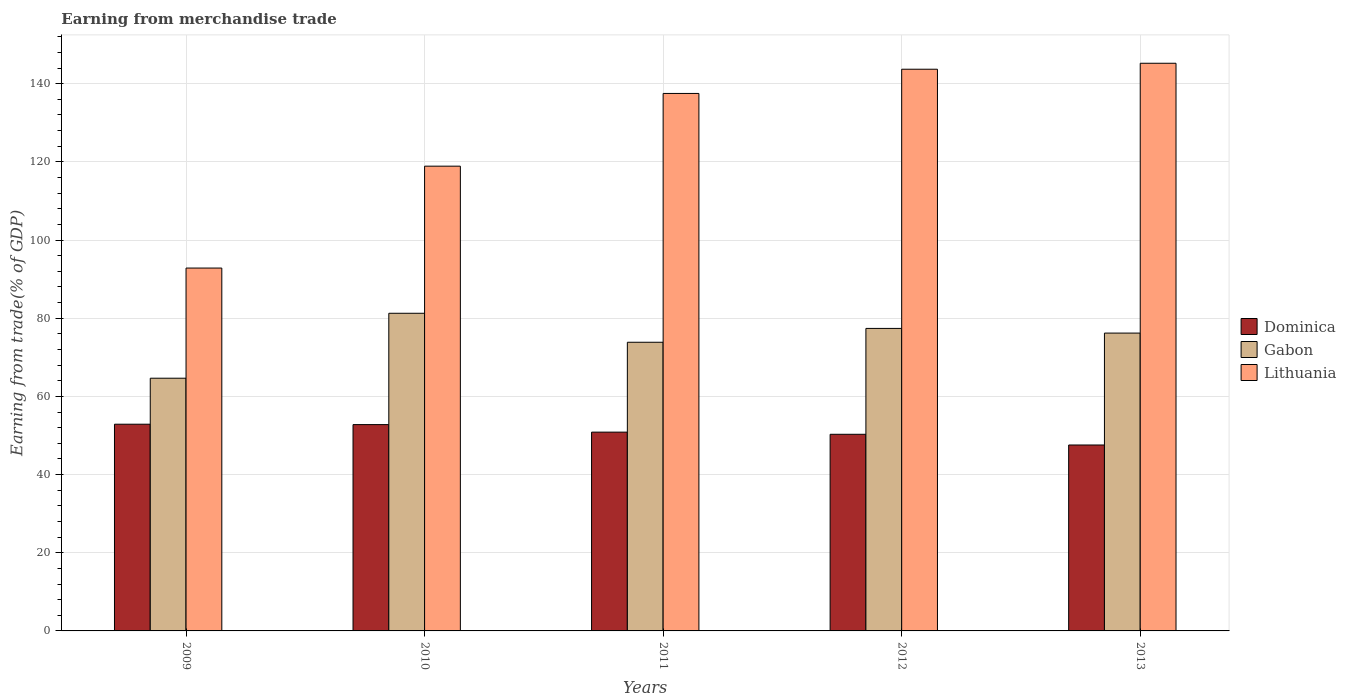How many different coloured bars are there?
Make the answer very short. 3. Are the number of bars on each tick of the X-axis equal?
Your answer should be compact. Yes. How many bars are there on the 2nd tick from the left?
Your answer should be very brief. 3. How many bars are there on the 4th tick from the right?
Give a very brief answer. 3. What is the label of the 5th group of bars from the left?
Your answer should be compact. 2013. What is the earnings from trade in Gabon in 2013?
Your answer should be compact. 76.2. Across all years, what is the maximum earnings from trade in Gabon?
Make the answer very short. 81.26. Across all years, what is the minimum earnings from trade in Gabon?
Give a very brief answer. 64.65. What is the total earnings from trade in Gabon in the graph?
Keep it short and to the point. 373.36. What is the difference between the earnings from trade in Dominica in 2009 and that in 2012?
Provide a succinct answer. 2.58. What is the difference between the earnings from trade in Dominica in 2011 and the earnings from trade in Gabon in 2010?
Give a very brief answer. -30.41. What is the average earnings from trade in Dominica per year?
Give a very brief answer. 50.88. In the year 2010, what is the difference between the earnings from trade in Dominica and earnings from trade in Gabon?
Ensure brevity in your answer.  -28.48. In how many years, is the earnings from trade in Gabon greater than 16 %?
Provide a short and direct response. 5. What is the ratio of the earnings from trade in Gabon in 2009 to that in 2010?
Provide a succinct answer. 0.8. Is the earnings from trade in Dominica in 2011 less than that in 2012?
Provide a succinct answer. No. What is the difference between the highest and the second highest earnings from trade in Gabon?
Your response must be concise. 3.87. What is the difference between the highest and the lowest earnings from trade in Lithuania?
Provide a short and direct response. 52.39. In how many years, is the earnings from trade in Gabon greater than the average earnings from trade in Gabon taken over all years?
Give a very brief answer. 3. What does the 1st bar from the left in 2010 represents?
Offer a terse response. Dominica. What does the 3rd bar from the right in 2009 represents?
Ensure brevity in your answer.  Dominica. What is the difference between two consecutive major ticks on the Y-axis?
Give a very brief answer. 20. Are the values on the major ticks of Y-axis written in scientific E-notation?
Ensure brevity in your answer.  No. Does the graph contain grids?
Keep it short and to the point. Yes. Where does the legend appear in the graph?
Provide a succinct answer. Center right. How are the legend labels stacked?
Ensure brevity in your answer.  Vertical. What is the title of the graph?
Offer a terse response. Earning from merchandise trade. Does "Swaziland" appear as one of the legend labels in the graph?
Offer a very short reply. No. What is the label or title of the X-axis?
Give a very brief answer. Years. What is the label or title of the Y-axis?
Your answer should be very brief. Earning from trade(% of GDP). What is the Earning from trade(% of GDP) in Dominica in 2009?
Give a very brief answer. 52.88. What is the Earning from trade(% of GDP) of Gabon in 2009?
Give a very brief answer. 64.65. What is the Earning from trade(% of GDP) of Lithuania in 2009?
Offer a terse response. 92.84. What is the Earning from trade(% of GDP) of Dominica in 2010?
Your response must be concise. 52.78. What is the Earning from trade(% of GDP) in Gabon in 2010?
Make the answer very short. 81.26. What is the Earning from trade(% of GDP) of Lithuania in 2010?
Provide a short and direct response. 118.9. What is the Earning from trade(% of GDP) in Dominica in 2011?
Provide a succinct answer. 50.86. What is the Earning from trade(% of GDP) of Gabon in 2011?
Provide a succinct answer. 73.85. What is the Earning from trade(% of GDP) in Lithuania in 2011?
Your answer should be compact. 137.51. What is the Earning from trade(% of GDP) in Dominica in 2012?
Offer a very short reply. 50.3. What is the Earning from trade(% of GDP) in Gabon in 2012?
Ensure brevity in your answer.  77.39. What is the Earning from trade(% of GDP) of Lithuania in 2012?
Keep it short and to the point. 143.7. What is the Earning from trade(% of GDP) in Dominica in 2013?
Your answer should be compact. 47.57. What is the Earning from trade(% of GDP) in Gabon in 2013?
Keep it short and to the point. 76.2. What is the Earning from trade(% of GDP) of Lithuania in 2013?
Offer a very short reply. 145.23. Across all years, what is the maximum Earning from trade(% of GDP) of Dominica?
Ensure brevity in your answer.  52.88. Across all years, what is the maximum Earning from trade(% of GDP) of Gabon?
Make the answer very short. 81.26. Across all years, what is the maximum Earning from trade(% of GDP) in Lithuania?
Ensure brevity in your answer.  145.23. Across all years, what is the minimum Earning from trade(% of GDP) of Dominica?
Your answer should be very brief. 47.57. Across all years, what is the minimum Earning from trade(% of GDP) of Gabon?
Your answer should be compact. 64.65. Across all years, what is the minimum Earning from trade(% of GDP) in Lithuania?
Give a very brief answer. 92.84. What is the total Earning from trade(% of GDP) of Dominica in the graph?
Ensure brevity in your answer.  254.4. What is the total Earning from trade(% of GDP) in Gabon in the graph?
Your answer should be very brief. 373.36. What is the total Earning from trade(% of GDP) of Lithuania in the graph?
Give a very brief answer. 638.18. What is the difference between the Earning from trade(% of GDP) of Dominica in 2009 and that in 2010?
Keep it short and to the point. 0.1. What is the difference between the Earning from trade(% of GDP) of Gabon in 2009 and that in 2010?
Your answer should be compact. -16.61. What is the difference between the Earning from trade(% of GDP) in Lithuania in 2009 and that in 2010?
Offer a terse response. -26.07. What is the difference between the Earning from trade(% of GDP) in Dominica in 2009 and that in 2011?
Ensure brevity in your answer.  2.03. What is the difference between the Earning from trade(% of GDP) in Gabon in 2009 and that in 2011?
Offer a terse response. -9.2. What is the difference between the Earning from trade(% of GDP) in Lithuania in 2009 and that in 2011?
Offer a terse response. -44.67. What is the difference between the Earning from trade(% of GDP) in Dominica in 2009 and that in 2012?
Keep it short and to the point. 2.58. What is the difference between the Earning from trade(% of GDP) in Gabon in 2009 and that in 2012?
Keep it short and to the point. -12.74. What is the difference between the Earning from trade(% of GDP) of Lithuania in 2009 and that in 2012?
Provide a succinct answer. -50.87. What is the difference between the Earning from trade(% of GDP) in Dominica in 2009 and that in 2013?
Your answer should be compact. 5.32. What is the difference between the Earning from trade(% of GDP) in Gabon in 2009 and that in 2013?
Provide a succinct answer. -11.54. What is the difference between the Earning from trade(% of GDP) of Lithuania in 2009 and that in 2013?
Provide a short and direct response. -52.39. What is the difference between the Earning from trade(% of GDP) in Dominica in 2010 and that in 2011?
Keep it short and to the point. 1.93. What is the difference between the Earning from trade(% of GDP) in Gabon in 2010 and that in 2011?
Make the answer very short. 7.42. What is the difference between the Earning from trade(% of GDP) of Lithuania in 2010 and that in 2011?
Offer a very short reply. -18.61. What is the difference between the Earning from trade(% of GDP) of Dominica in 2010 and that in 2012?
Your answer should be compact. 2.48. What is the difference between the Earning from trade(% of GDP) in Gabon in 2010 and that in 2012?
Provide a succinct answer. 3.87. What is the difference between the Earning from trade(% of GDP) of Lithuania in 2010 and that in 2012?
Your response must be concise. -24.8. What is the difference between the Earning from trade(% of GDP) of Dominica in 2010 and that in 2013?
Provide a succinct answer. 5.22. What is the difference between the Earning from trade(% of GDP) of Gabon in 2010 and that in 2013?
Provide a succinct answer. 5.07. What is the difference between the Earning from trade(% of GDP) in Lithuania in 2010 and that in 2013?
Your answer should be very brief. -26.33. What is the difference between the Earning from trade(% of GDP) of Dominica in 2011 and that in 2012?
Keep it short and to the point. 0.56. What is the difference between the Earning from trade(% of GDP) in Gabon in 2011 and that in 2012?
Your answer should be compact. -3.54. What is the difference between the Earning from trade(% of GDP) in Lithuania in 2011 and that in 2012?
Provide a succinct answer. -6.2. What is the difference between the Earning from trade(% of GDP) in Dominica in 2011 and that in 2013?
Provide a succinct answer. 3.29. What is the difference between the Earning from trade(% of GDP) in Gabon in 2011 and that in 2013?
Your answer should be very brief. -2.35. What is the difference between the Earning from trade(% of GDP) of Lithuania in 2011 and that in 2013?
Provide a short and direct response. -7.72. What is the difference between the Earning from trade(% of GDP) in Dominica in 2012 and that in 2013?
Your answer should be compact. 2.74. What is the difference between the Earning from trade(% of GDP) of Gabon in 2012 and that in 2013?
Give a very brief answer. 1.2. What is the difference between the Earning from trade(% of GDP) of Lithuania in 2012 and that in 2013?
Keep it short and to the point. -1.53. What is the difference between the Earning from trade(% of GDP) in Dominica in 2009 and the Earning from trade(% of GDP) in Gabon in 2010?
Provide a succinct answer. -28.38. What is the difference between the Earning from trade(% of GDP) of Dominica in 2009 and the Earning from trade(% of GDP) of Lithuania in 2010?
Provide a short and direct response. -66.02. What is the difference between the Earning from trade(% of GDP) in Gabon in 2009 and the Earning from trade(% of GDP) in Lithuania in 2010?
Your response must be concise. -54.25. What is the difference between the Earning from trade(% of GDP) in Dominica in 2009 and the Earning from trade(% of GDP) in Gabon in 2011?
Give a very brief answer. -20.97. What is the difference between the Earning from trade(% of GDP) in Dominica in 2009 and the Earning from trade(% of GDP) in Lithuania in 2011?
Offer a terse response. -84.62. What is the difference between the Earning from trade(% of GDP) of Gabon in 2009 and the Earning from trade(% of GDP) of Lithuania in 2011?
Offer a terse response. -72.85. What is the difference between the Earning from trade(% of GDP) of Dominica in 2009 and the Earning from trade(% of GDP) of Gabon in 2012?
Your answer should be compact. -24.51. What is the difference between the Earning from trade(% of GDP) of Dominica in 2009 and the Earning from trade(% of GDP) of Lithuania in 2012?
Offer a terse response. -90.82. What is the difference between the Earning from trade(% of GDP) in Gabon in 2009 and the Earning from trade(% of GDP) in Lithuania in 2012?
Offer a very short reply. -79.05. What is the difference between the Earning from trade(% of GDP) of Dominica in 2009 and the Earning from trade(% of GDP) of Gabon in 2013?
Your answer should be compact. -23.31. What is the difference between the Earning from trade(% of GDP) of Dominica in 2009 and the Earning from trade(% of GDP) of Lithuania in 2013?
Provide a succinct answer. -92.34. What is the difference between the Earning from trade(% of GDP) of Gabon in 2009 and the Earning from trade(% of GDP) of Lithuania in 2013?
Offer a terse response. -80.58. What is the difference between the Earning from trade(% of GDP) in Dominica in 2010 and the Earning from trade(% of GDP) in Gabon in 2011?
Offer a terse response. -21.07. What is the difference between the Earning from trade(% of GDP) of Dominica in 2010 and the Earning from trade(% of GDP) of Lithuania in 2011?
Your answer should be very brief. -84.72. What is the difference between the Earning from trade(% of GDP) of Gabon in 2010 and the Earning from trade(% of GDP) of Lithuania in 2011?
Your response must be concise. -56.24. What is the difference between the Earning from trade(% of GDP) in Dominica in 2010 and the Earning from trade(% of GDP) in Gabon in 2012?
Ensure brevity in your answer.  -24.61. What is the difference between the Earning from trade(% of GDP) in Dominica in 2010 and the Earning from trade(% of GDP) in Lithuania in 2012?
Make the answer very short. -90.92. What is the difference between the Earning from trade(% of GDP) in Gabon in 2010 and the Earning from trade(% of GDP) in Lithuania in 2012?
Give a very brief answer. -62.44. What is the difference between the Earning from trade(% of GDP) in Dominica in 2010 and the Earning from trade(% of GDP) in Gabon in 2013?
Your response must be concise. -23.41. What is the difference between the Earning from trade(% of GDP) of Dominica in 2010 and the Earning from trade(% of GDP) of Lithuania in 2013?
Give a very brief answer. -92.44. What is the difference between the Earning from trade(% of GDP) in Gabon in 2010 and the Earning from trade(% of GDP) in Lithuania in 2013?
Keep it short and to the point. -63.96. What is the difference between the Earning from trade(% of GDP) of Dominica in 2011 and the Earning from trade(% of GDP) of Gabon in 2012?
Provide a succinct answer. -26.53. What is the difference between the Earning from trade(% of GDP) of Dominica in 2011 and the Earning from trade(% of GDP) of Lithuania in 2012?
Give a very brief answer. -92.84. What is the difference between the Earning from trade(% of GDP) of Gabon in 2011 and the Earning from trade(% of GDP) of Lithuania in 2012?
Make the answer very short. -69.85. What is the difference between the Earning from trade(% of GDP) in Dominica in 2011 and the Earning from trade(% of GDP) in Gabon in 2013?
Make the answer very short. -25.34. What is the difference between the Earning from trade(% of GDP) in Dominica in 2011 and the Earning from trade(% of GDP) in Lithuania in 2013?
Ensure brevity in your answer.  -94.37. What is the difference between the Earning from trade(% of GDP) of Gabon in 2011 and the Earning from trade(% of GDP) of Lithuania in 2013?
Give a very brief answer. -71.38. What is the difference between the Earning from trade(% of GDP) in Dominica in 2012 and the Earning from trade(% of GDP) in Gabon in 2013?
Give a very brief answer. -25.89. What is the difference between the Earning from trade(% of GDP) of Dominica in 2012 and the Earning from trade(% of GDP) of Lithuania in 2013?
Ensure brevity in your answer.  -94.92. What is the difference between the Earning from trade(% of GDP) of Gabon in 2012 and the Earning from trade(% of GDP) of Lithuania in 2013?
Ensure brevity in your answer.  -67.84. What is the average Earning from trade(% of GDP) in Dominica per year?
Give a very brief answer. 50.88. What is the average Earning from trade(% of GDP) of Gabon per year?
Your response must be concise. 74.67. What is the average Earning from trade(% of GDP) in Lithuania per year?
Offer a terse response. 127.64. In the year 2009, what is the difference between the Earning from trade(% of GDP) in Dominica and Earning from trade(% of GDP) in Gabon?
Your answer should be very brief. -11.77. In the year 2009, what is the difference between the Earning from trade(% of GDP) of Dominica and Earning from trade(% of GDP) of Lithuania?
Your answer should be compact. -39.95. In the year 2009, what is the difference between the Earning from trade(% of GDP) of Gabon and Earning from trade(% of GDP) of Lithuania?
Your response must be concise. -28.18. In the year 2010, what is the difference between the Earning from trade(% of GDP) of Dominica and Earning from trade(% of GDP) of Gabon?
Make the answer very short. -28.48. In the year 2010, what is the difference between the Earning from trade(% of GDP) in Dominica and Earning from trade(% of GDP) in Lithuania?
Your answer should be very brief. -66.12. In the year 2010, what is the difference between the Earning from trade(% of GDP) of Gabon and Earning from trade(% of GDP) of Lithuania?
Give a very brief answer. -37.64. In the year 2011, what is the difference between the Earning from trade(% of GDP) in Dominica and Earning from trade(% of GDP) in Gabon?
Offer a terse response. -22.99. In the year 2011, what is the difference between the Earning from trade(% of GDP) of Dominica and Earning from trade(% of GDP) of Lithuania?
Ensure brevity in your answer.  -86.65. In the year 2011, what is the difference between the Earning from trade(% of GDP) in Gabon and Earning from trade(% of GDP) in Lithuania?
Your answer should be compact. -63.66. In the year 2012, what is the difference between the Earning from trade(% of GDP) of Dominica and Earning from trade(% of GDP) of Gabon?
Provide a succinct answer. -27.09. In the year 2012, what is the difference between the Earning from trade(% of GDP) of Dominica and Earning from trade(% of GDP) of Lithuania?
Offer a terse response. -93.4. In the year 2012, what is the difference between the Earning from trade(% of GDP) in Gabon and Earning from trade(% of GDP) in Lithuania?
Your answer should be very brief. -66.31. In the year 2013, what is the difference between the Earning from trade(% of GDP) of Dominica and Earning from trade(% of GDP) of Gabon?
Offer a terse response. -28.63. In the year 2013, what is the difference between the Earning from trade(% of GDP) in Dominica and Earning from trade(% of GDP) in Lithuania?
Give a very brief answer. -97.66. In the year 2013, what is the difference between the Earning from trade(% of GDP) of Gabon and Earning from trade(% of GDP) of Lithuania?
Your response must be concise. -69.03. What is the ratio of the Earning from trade(% of GDP) in Dominica in 2009 to that in 2010?
Provide a short and direct response. 1. What is the ratio of the Earning from trade(% of GDP) of Gabon in 2009 to that in 2010?
Make the answer very short. 0.8. What is the ratio of the Earning from trade(% of GDP) in Lithuania in 2009 to that in 2010?
Keep it short and to the point. 0.78. What is the ratio of the Earning from trade(% of GDP) of Dominica in 2009 to that in 2011?
Your answer should be very brief. 1.04. What is the ratio of the Earning from trade(% of GDP) of Gabon in 2009 to that in 2011?
Give a very brief answer. 0.88. What is the ratio of the Earning from trade(% of GDP) in Lithuania in 2009 to that in 2011?
Offer a very short reply. 0.68. What is the ratio of the Earning from trade(% of GDP) in Dominica in 2009 to that in 2012?
Your response must be concise. 1.05. What is the ratio of the Earning from trade(% of GDP) of Gabon in 2009 to that in 2012?
Your answer should be compact. 0.84. What is the ratio of the Earning from trade(% of GDP) of Lithuania in 2009 to that in 2012?
Offer a terse response. 0.65. What is the ratio of the Earning from trade(% of GDP) in Dominica in 2009 to that in 2013?
Provide a succinct answer. 1.11. What is the ratio of the Earning from trade(% of GDP) of Gabon in 2009 to that in 2013?
Your answer should be very brief. 0.85. What is the ratio of the Earning from trade(% of GDP) of Lithuania in 2009 to that in 2013?
Provide a short and direct response. 0.64. What is the ratio of the Earning from trade(% of GDP) of Dominica in 2010 to that in 2011?
Keep it short and to the point. 1.04. What is the ratio of the Earning from trade(% of GDP) in Gabon in 2010 to that in 2011?
Provide a short and direct response. 1.1. What is the ratio of the Earning from trade(% of GDP) of Lithuania in 2010 to that in 2011?
Keep it short and to the point. 0.86. What is the ratio of the Earning from trade(% of GDP) in Dominica in 2010 to that in 2012?
Provide a succinct answer. 1.05. What is the ratio of the Earning from trade(% of GDP) in Gabon in 2010 to that in 2012?
Offer a very short reply. 1.05. What is the ratio of the Earning from trade(% of GDP) in Lithuania in 2010 to that in 2012?
Give a very brief answer. 0.83. What is the ratio of the Earning from trade(% of GDP) of Dominica in 2010 to that in 2013?
Keep it short and to the point. 1.11. What is the ratio of the Earning from trade(% of GDP) of Gabon in 2010 to that in 2013?
Offer a very short reply. 1.07. What is the ratio of the Earning from trade(% of GDP) in Lithuania in 2010 to that in 2013?
Offer a very short reply. 0.82. What is the ratio of the Earning from trade(% of GDP) in Dominica in 2011 to that in 2012?
Give a very brief answer. 1.01. What is the ratio of the Earning from trade(% of GDP) of Gabon in 2011 to that in 2012?
Give a very brief answer. 0.95. What is the ratio of the Earning from trade(% of GDP) in Lithuania in 2011 to that in 2012?
Your response must be concise. 0.96. What is the ratio of the Earning from trade(% of GDP) in Dominica in 2011 to that in 2013?
Give a very brief answer. 1.07. What is the ratio of the Earning from trade(% of GDP) in Gabon in 2011 to that in 2013?
Your response must be concise. 0.97. What is the ratio of the Earning from trade(% of GDP) of Lithuania in 2011 to that in 2013?
Make the answer very short. 0.95. What is the ratio of the Earning from trade(% of GDP) of Dominica in 2012 to that in 2013?
Keep it short and to the point. 1.06. What is the ratio of the Earning from trade(% of GDP) of Gabon in 2012 to that in 2013?
Your answer should be compact. 1.02. What is the ratio of the Earning from trade(% of GDP) in Lithuania in 2012 to that in 2013?
Keep it short and to the point. 0.99. What is the difference between the highest and the second highest Earning from trade(% of GDP) in Dominica?
Your response must be concise. 0.1. What is the difference between the highest and the second highest Earning from trade(% of GDP) of Gabon?
Provide a short and direct response. 3.87. What is the difference between the highest and the second highest Earning from trade(% of GDP) in Lithuania?
Offer a terse response. 1.53. What is the difference between the highest and the lowest Earning from trade(% of GDP) in Dominica?
Your answer should be very brief. 5.32. What is the difference between the highest and the lowest Earning from trade(% of GDP) of Gabon?
Offer a terse response. 16.61. What is the difference between the highest and the lowest Earning from trade(% of GDP) in Lithuania?
Give a very brief answer. 52.39. 